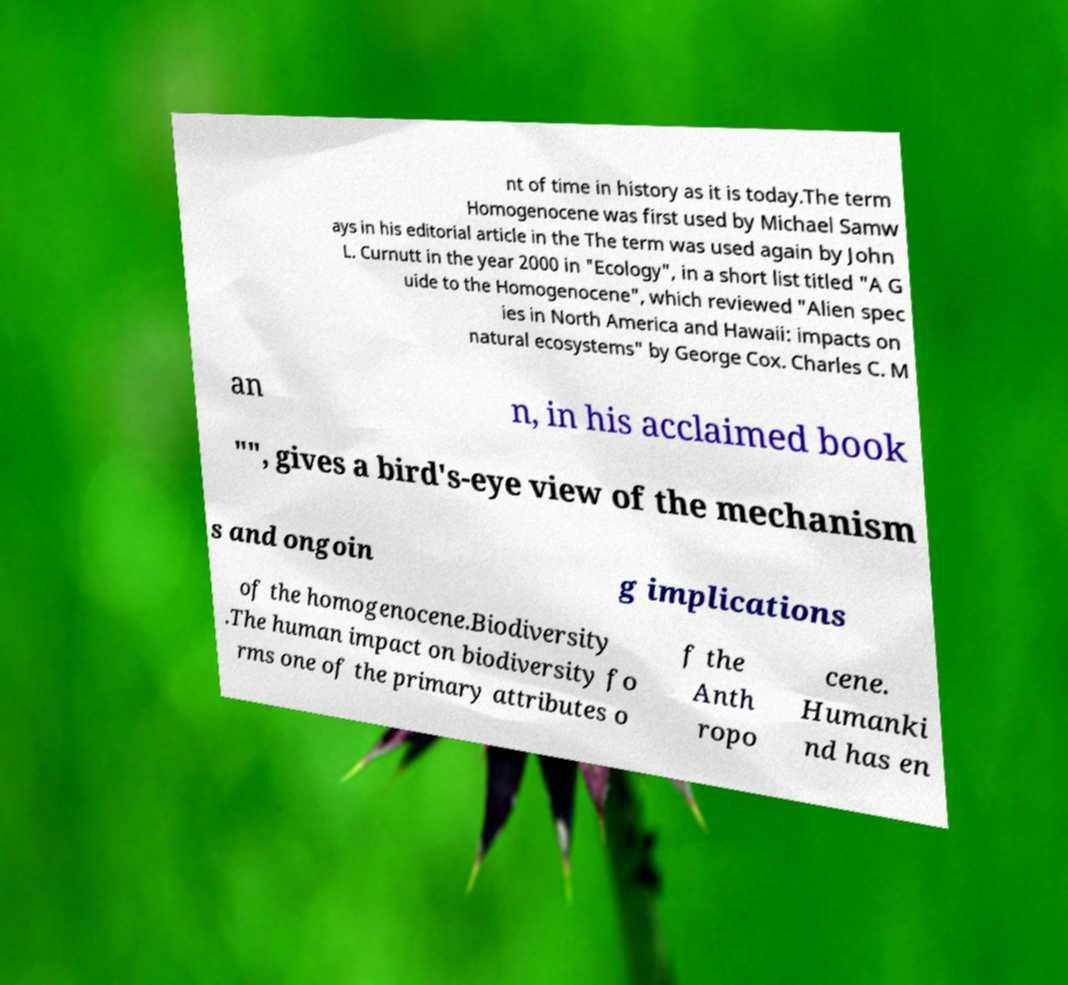What messages or text are displayed in this image? I need them in a readable, typed format. nt of time in history as it is today.The term Homogenocene was first used by Michael Samw ays in his editorial article in the The term was used again by John L. Curnutt in the year 2000 in "Ecology", in a short list titled "A G uide to the Homogenocene", which reviewed "Alien spec ies in North America and Hawaii: impacts on natural ecosystems" by George Cox. Charles C. M an n, in his acclaimed book "", gives a bird's-eye view of the mechanism s and ongoin g implications of the homogenocene.Biodiversity .The human impact on biodiversity fo rms one of the primary attributes o f the Anth ropo cene. Humanki nd has en 